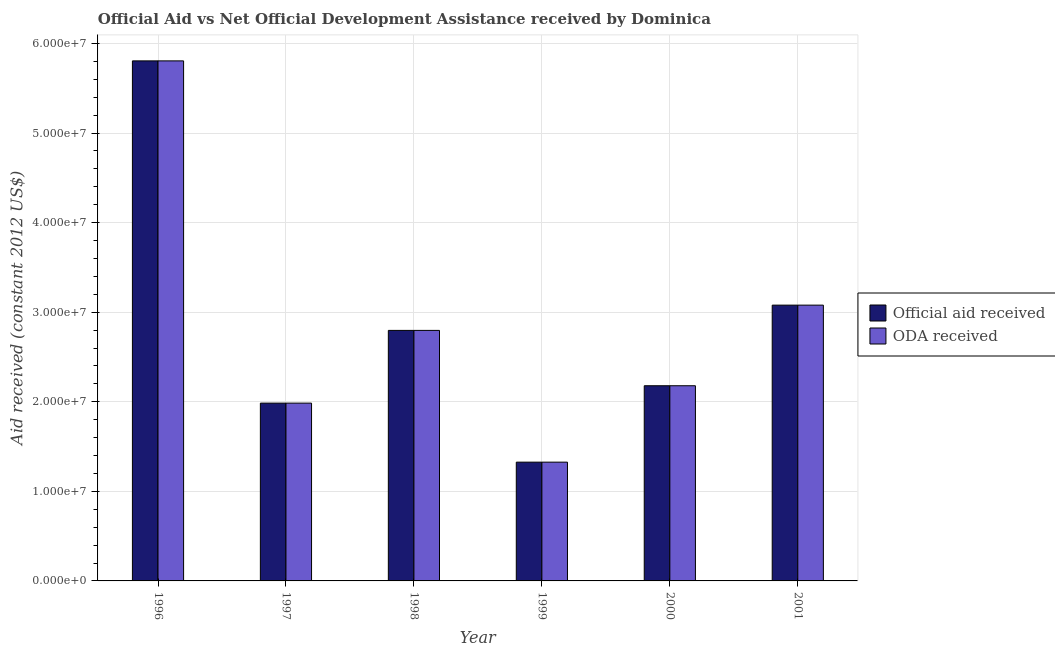How many groups of bars are there?
Offer a very short reply. 6. Are the number of bars on each tick of the X-axis equal?
Make the answer very short. Yes. How many bars are there on the 5th tick from the right?
Make the answer very short. 2. What is the oda received in 1996?
Give a very brief answer. 5.81e+07. Across all years, what is the maximum official aid received?
Keep it short and to the point. 5.81e+07. Across all years, what is the minimum official aid received?
Offer a very short reply. 1.33e+07. What is the total official aid received in the graph?
Provide a short and direct response. 1.72e+08. What is the difference between the official aid received in 1999 and that in 2001?
Make the answer very short. -1.75e+07. What is the difference between the oda received in 1997 and the official aid received in 1999?
Your answer should be very brief. 6.59e+06. What is the average oda received per year?
Your answer should be compact. 2.86e+07. What is the ratio of the oda received in 1998 to that in 1999?
Keep it short and to the point. 2.11. Is the official aid received in 1997 less than that in 1999?
Ensure brevity in your answer.  No. What is the difference between the highest and the second highest official aid received?
Offer a terse response. 2.73e+07. What is the difference between the highest and the lowest oda received?
Offer a very short reply. 4.48e+07. In how many years, is the oda received greater than the average oda received taken over all years?
Keep it short and to the point. 2. What does the 1st bar from the left in 1999 represents?
Make the answer very short. Official aid received. What does the 1st bar from the right in 1996 represents?
Give a very brief answer. ODA received. How many bars are there?
Offer a very short reply. 12. Are all the bars in the graph horizontal?
Give a very brief answer. No. How many years are there in the graph?
Your answer should be very brief. 6. Does the graph contain any zero values?
Make the answer very short. No. Does the graph contain grids?
Ensure brevity in your answer.  Yes. How many legend labels are there?
Your response must be concise. 2. How are the legend labels stacked?
Keep it short and to the point. Vertical. What is the title of the graph?
Make the answer very short. Official Aid vs Net Official Development Assistance received by Dominica . What is the label or title of the X-axis?
Provide a short and direct response. Year. What is the label or title of the Y-axis?
Ensure brevity in your answer.  Aid received (constant 2012 US$). What is the Aid received (constant 2012 US$) of Official aid received in 1996?
Ensure brevity in your answer.  5.81e+07. What is the Aid received (constant 2012 US$) of ODA received in 1996?
Offer a very short reply. 5.81e+07. What is the Aid received (constant 2012 US$) in Official aid received in 1997?
Your answer should be very brief. 1.98e+07. What is the Aid received (constant 2012 US$) in ODA received in 1997?
Keep it short and to the point. 1.98e+07. What is the Aid received (constant 2012 US$) of Official aid received in 1998?
Your answer should be very brief. 2.80e+07. What is the Aid received (constant 2012 US$) in ODA received in 1998?
Provide a succinct answer. 2.80e+07. What is the Aid received (constant 2012 US$) of Official aid received in 1999?
Offer a terse response. 1.33e+07. What is the Aid received (constant 2012 US$) of ODA received in 1999?
Your response must be concise. 1.33e+07. What is the Aid received (constant 2012 US$) of Official aid received in 2000?
Your answer should be compact. 2.18e+07. What is the Aid received (constant 2012 US$) in ODA received in 2000?
Offer a terse response. 2.18e+07. What is the Aid received (constant 2012 US$) in Official aid received in 2001?
Make the answer very short. 3.08e+07. What is the Aid received (constant 2012 US$) of ODA received in 2001?
Your answer should be very brief. 3.08e+07. Across all years, what is the maximum Aid received (constant 2012 US$) in Official aid received?
Offer a terse response. 5.81e+07. Across all years, what is the maximum Aid received (constant 2012 US$) of ODA received?
Your answer should be compact. 5.81e+07. Across all years, what is the minimum Aid received (constant 2012 US$) of Official aid received?
Keep it short and to the point. 1.33e+07. Across all years, what is the minimum Aid received (constant 2012 US$) of ODA received?
Make the answer very short. 1.33e+07. What is the total Aid received (constant 2012 US$) in Official aid received in the graph?
Keep it short and to the point. 1.72e+08. What is the total Aid received (constant 2012 US$) in ODA received in the graph?
Give a very brief answer. 1.72e+08. What is the difference between the Aid received (constant 2012 US$) of Official aid received in 1996 and that in 1997?
Keep it short and to the point. 3.82e+07. What is the difference between the Aid received (constant 2012 US$) in ODA received in 1996 and that in 1997?
Keep it short and to the point. 3.82e+07. What is the difference between the Aid received (constant 2012 US$) of Official aid received in 1996 and that in 1998?
Make the answer very short. 3.01e+07. What is the difference between the Aid received (constant 2012 US$) in ODA received in 1996 and that in 1998?
Ensure brevity in your answer.  3.01e+07. What is the difference between the Aid received (constant 2012 US$) in Official aid received in 1996 and that in 1999?
Offer a very short reply. 4.48e+07. What is the difference between the Aid received (constant 2012 US$) in ODA received in 1996 and that in 1999?
Keep it short and to the point. 4.48e+07. What is the difference between the Aid received (constant 2012 US$) in Official aid received in 1996 and that in 2000?
Your response must be concise. 3.63e+07. What is the difference between the Aid received (constant 2012 US$) in ODA received in 1996 and that in 2000?
Offer a terse response. 3.63e+07. What is the difference between the Aid received (constant 2012 US$) of Official aid received in 1996 and that in 2001?
Provide a short and direct response. 2.73e+07. What is the difference between the Aid received (constant 2012 US$) in ODA received in 1996 and that in 2001?
Your answer should be very brief. 2.73e+07. What is the difference between the Aid received (constant 2012 US$) of Official aid received in 1997 and that in 1998?
Your answer should be compact. -8.12e+06. What is the difference between the Aid received (constant 2012 US$) of ODA received in 1997 and that in 1998?
Keep it short and to the point. -8.12e+06. What is the difference between the Aid received (constant 2012 US$) of Official aid received in 1997 and that in 1999?
Your answer should be very brief. 6.59e+06. What is the difference between the Aid received (constant 2012 US$) of ODA received in 1997 and that in 1999?
Your response must be concise. 6.59e+06. What is the difference between the Aid received (constant 2012 US$) of Official aid received in 1997 and that in 2000?
Make the answer very short. -1.94e+06. What is the difference between the Aid received (constant 2012 US$) of ODA received in 1997 and that in 2000?
Give a very brief answer. -1.94e+06. What is the difference between the Aid received (constant 2012 US$) in Official aid received in 1997 and that in 2001?
Ensure brevity in your answer.  -1.09e+07. What is the difference between the Aid received (constant 2012 US$) of ODA received in 1997 and that in 2001?
Provide a succinct answer. -1.09e+07. What is the difference between the Aid received (constant 2012 US$) of Official aid received in 1998 and that in 1999?
Your answer should be compact. 1.47e+07. What is the difference between the Aid received (constant 2012 US$) in ODA received in 1998 and that in 1999?
Provide a short and direct response. 1.47e+07. What is the difference between the Aid received (constant 2012 US$) in Official aid received in 1998 and that in 2000?
Offer a very short reply. 6.18e+06. What is the difference between the Aid received (constant 2012 US$) of ODA received in 1998 and that in 2000?
Provide a short and direct response. 6.18e+06. What is the difference between the Aid received (constant 2012 US$) of Official aid received in 1998 and that in 2001?
Your answer should be very brief. -2.82e+06. What is the difference between the Aid received (constant 2012 US$) in ODA received in 1998 and that in 2001?
Your answer should be compact. -2.82e+06. What is the difference between the Aid received (constant 2012 US$) in Official aid received in 1999 and that in 2000?
Your answer should be very brief. -8.53e+06. What is the difference between the Aid received (constant 2012 US$) in ODA received in 1999 and that in 2000?
Keep it short and to the point. -8.53e+06. What is the difference between the Aid received (constant 2012 US$) of Official aid received in 1999 and that in 2001?
Give a very brief answer. -1.75e+07. What is the difference between the Aid received (constant 2012 US$) of ODA received in 1999 and that in 2001?
Provide a succinct answer. -1.75e+07. What is the difference between the Aid received (constant 2012 US$) in Official aid received in 2000 and that in 2001?
Offer a terse response. -9.00e+06. What is the difference between the Aid received (constant 2012 US$) in ODA received in 2000 and that in 2001?
Your answer should be compact. -9.00e+06. What is the difference between the Aid received (constant 2012 US$) in Official aid received in 1996 and the Aid received (constant 2012 US$) in ODA received in 1997?
Your answer should be compact. 3.82e+07. What is the difference between the Aid received (constant 2012 US$) of Official aid received in 1996 and the Aid received (constant 2012 US$) of ODA received in 1998?
Ensure brevity in your answer.  3.01e+07. What is the difference between the Aid received (constant 2012 US$) of Official aid received in 1996 and the Aid received (constant 2012 US$) of ODA received in 1999?
Your answer should be compact. 4.48e+07. What is the difference between the Aid received (constant 2012 US$) in Official aid received in 1996 and the Aid received (constant 2012 US$) in ODA received in 2000?
Your answer should be compact. 3.63e+07. What is the difference between the Aid received (constant 2012 US$) in Official aid received in 1996 and the Aid received (constant 2012 US$) in ODA received in 2001?
Make the answer very short. 2.73e+07. What is the difference between the Aid received (constant 2012 US$) in Official aid received in 1997 and the Aid received (constant 2012 US$) in ODA received in 1998?
Give a very brief answer. -8.12e+06. What is the difference between the Aid received (constant 2012 US$) in Official aid received in 1997 and the Aid received (constant 2012 US$) in ODA received in 1999?
Provide a succinct answer. 6.59e+06. What is the difference between the Aid received (constant 2012 US$) of Official aid received in 1997 and the Aid received (constant 2012 US$) of ODA received in 2000?
Offer a terse response. -1.94e+06. What is the difference between the Aid received (constant 2012 US$) of Official aid received in 1997 and the Aid received (constant 2012 US$) of ODA received in 2001?
Provide a short and direct response. -1.09e+07. What is the difference between the Aid received (constant 2012 US$) in Official aid received in 1998 and the Aid received (constant 2012 US$) in ODA received in 1999?
Your response must be concise. 1.47e+07. What is the difference between the Aid received (constant 2012 US$) in Official aid received in 1998 and the Aid received (constant 2012 US$) in ODA received in 2000?
Ensure brevity in your answer.  6.18e+06. What is the difference between the Aid received (constant 2012 US$) of Official aid received in 1998 and the Aid received (constant 2012 US$) of ODA received in 2001?
Give a very brief answer. -2.82e+06. What is the difference between the Aid received (constant 2012 US$) in Official aid received in 1999 and the Aid received (constant 2012 US$) in ODA received in 2000?
Provide a succinct answer. -8.53e+06. What is the difference between the Aid received (constant 2012 US$) of Official aid received in 1999 and the Aid received (constant 2012 US$) of ODA received in 2001?
Your answer should be compact. -1.75e+07. What is the difference between the Aid received (constant 2012 US$) of Official aid received in 2000 and the Aid received (constant 2012 US$) of ODA received in 2001?
Keep it short and to the point. -9.00e+06. What is the average Aid received (constant 2012 US$) in Official aid received per year?
Give a very brief answer. 2.86e+07. What is the average Aid received (constant 2012 US$) of ODA received per year?
Make the answer very short. 2.86e+07. In the year 1996, what is the difference between the Aid received (constant 2012 US$) of Official aid received and Aid received (constant 2012 US$) of ODA received?
Provide a succinct answer. 0. In the year 1997, what is the difference between the Aid received (constant 2012 US$) in Official aid received and Aid received (constant 2012 US$) in ODA received?
Your answer should be compact. 0. In the year 1998, what is the difference between the Aid received (constant 2012 US$) in Official aid received and Aid received (constant 2012 US$) in ODA received?
Offer a terse response. 0. What is the ratio of the Aid received (constant 2012 US$) in Official aid received in 1996 to that in 1997?
Your response must be concise. 2.92. What is the ratio of the Aid received (constant 2012 US$) in ODA received in 1996 to that in 1997?
Offer a terse response. 2.92. What is the ratio of the Aid received (constant 2012 US$) of Official aid received in 1996 to that in 1998?
Offer a very short reply. 2.08. What is the ratio of the Aid received (constant 2012 US$) in ODA received in 1996 to that in 1998?
Offer a terse response. 2.08. What is the ratio of the Aid received (constant 2012 US$) of Official aid received in 1996 to that in 1999?
Your answer should be compact. 4.38. What is the ratio of the Aid received (constant 2012 US$) of ODA received in 1996 to that in 1999?
Offer a very short reply. 4.38. What is the ratio of the Aid received (constant 2012 US$) in Official aid received in 1996 to that in 2000?
Make the answer very short. 2.66. What is the ratio of the Aid received (constant 2012 US$) of ODA received in 1996 to that in 2000?
Provide a succinct answer. 2.66. What is the ratio of the Aid received (constant 2012 US$) in Official aid received in 1996 to that in 2001?
Keep it short and to the point. 1.89. What is the ratio of the Aid received (constant 2012 US$) in ODA received in 1996 to that in 2001?
Offer a very short reply. 1.89. What is the ratio of the Aid received (constant 2012 US$) in Official aid received in 1997 to that in 1998?
Keep it short and to the point. 0.71. What is the ratio of the Aid received (constant 2012 US$) of ODA received in 1997 to that in 1998?
Your answer should be very brief. 0.71. What is the ratio of the Aid received (constant 2012 US$) of Official aid received in 1997 to that in 1999?
Keep it short and to the point. 1.5. What is the ratio of the Aid received (constant 2012 US$) in ODA received in 1997 to that in 1999?
Your response must be concise. 1.5. What is the ratio of the Aid received (constant 2012 US$) of Official aid received in 1997 to that in 2000?
Provide a succinct answer. 0.91. What is the ratio of the Aid received (constant 2012 US$) in ODA received in 1997 to that in 2000?
Offer a terse response. 0.91. What is the ratio of the Aid received (constant 2012 US$) in Official aid received in 1997 to that in 2001?
Offer a terse response. 0.64. What is the ratio of the Aid received (constant 2012 US$) in ODA received in 1997 to that in 2001?
Make the answer very short. 0.64. What is the ratio of the Aid received (constant 2012 US$) in Official aid received in 1998 to that in 1999?
Provide a short and direct response. 2.11. What is the ratio of the Aid received (constant 2012 US$) in ODA received in 1998 to that in 1999?
Provide a succinct answer. 2.11. What is the ratio of the Aid received (constant 2012 US$) of Official aid received in 1998 to that in 2000?
Provide a succinct answer. 1.28. What is the ratio of the Aid received (constant 2012 US$) in ODA received in 1998 to that in 2000?
Offer a terse response. 1.28. What is the ratio of the Aid received (constant 2012 US$) of Official aid received in 1998 to that in 2001?
Provide a short and direct response. 0.91. What is the ratio of the Aid received (constant 2012 US$) of ODA received in 1998 to that in 2001?
Your answer should be compact. 0.91. What is the ratio of the Aid received (constant 2012 US$) in Official aid received in 1999 to that in 2000?
Keep it short and to the point. 0.61. What is the ratio of the Aid received (constant 2012 US$) of ODA received in 1999 to that in 2000?
Your response must be concise. 0.61. What is the ratio of the Aid received (constant 2012 US$) in Official aid received in 1999 to that in 2001?
Provide a short and direct response. 0.43. What is the ratio of the Aid received (constant 2012 US$) in ODA received in 1999 to that in 2001?
Your response must be concise. 0.43. What is the ratio of the Aid received (constant 2012 US$) of Official aid received in 2000 to that in 2001?
Give a very brief answer. 0.71. What is the ratio of the Aid received (constant 2012 US$) in ODA received in 2000 to that in 2001?
Your answer should be compact. 0.71. What is the difference between the highest and the second highest Aid received (constant 2012 US$) in Official aid received?
Your answer should be compact. 2.73e+07. What is the difference between the highest and the second highest Aid received (constant 2012 US$) in ODA received?
Provide a succinct answer. 2.73e+07. What is the difference between the highest and the lowest Aid received (constant 2012 US$) of Official aid received?
Keep it short and to the point. 4.48e+07. What is the difference between the highest and the lowest Aid received (constant 2012 US$) in ODA received?
Offer a terse response. 4.48e+07. 